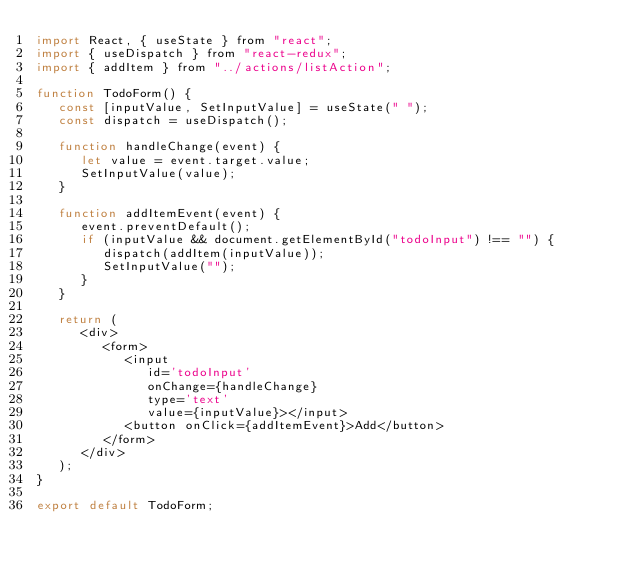Convert code to text. <code><loc_0><loc_0><loc_500><loc_500><_JavaScript_>import React, { useState } from "react";
import { useDispatch } from "react-redux";
import { addItem } from "../actions/listAction";

function TodoForm() {
   const [inputValue, SetInputValue] = useState(" ");
   const dispatch = useDispatch();

   function handleChange(event) {
      let value = event.target.value;
      SetInputValue(value);
   }

   function addItemEvent(event) {
      event.preventDefault();
      if (inputValue && document.getElementById("todoInput") !== "") {
         dispatch(addItem(inputValue));
         SetInputValue("");
      }
   }

   return (
      <div>
         <form>
            <input
               id='todoInput'
               onChange={handleChange}
               type='text'
               value={inputValue}></input>
            <button onClick={addItemEvent}>Add</button>
         </form>
      </div>
   );
}

export default TodoForm;
</code> 